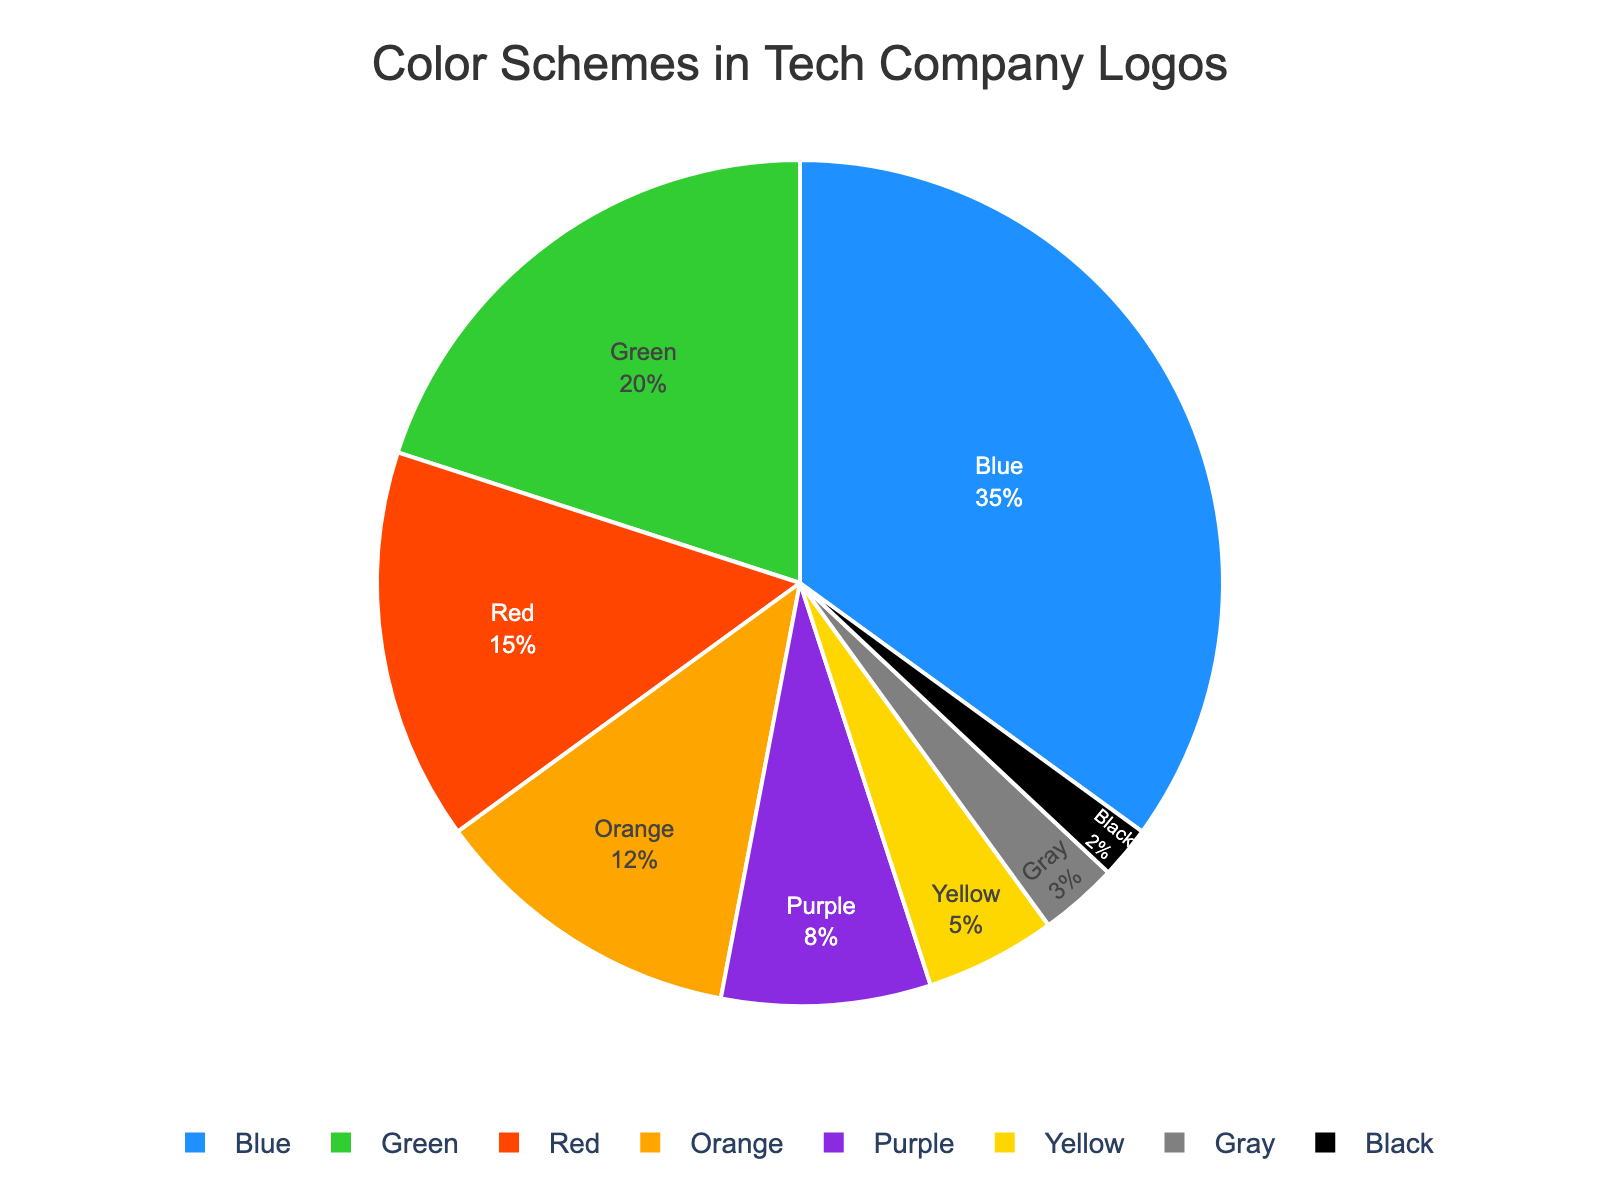Which color scheme is the most commonly used in tech company logos? From the pie chart, Blue holds the largest percentage, indicating it is the most commonly used color scheme.
Answer: Blue Which two colors together account for more than 50% of tech company logos? Blue has 35% and Green has 20%. Adding them together, Blue (35%) + Green (20%) = 55%, which is more than 50%.
Answer: Blue and Green How much more common is the Blue color scheme compared to the Red color scheme in tech company logos? Blue is at 35% and Red is at 15%. The difference is calculated as 35% - 15% = 20%.
Answer: 20% What is the percentage of tech company logos that use either Orange or Purple color schemes? Orange is at 12% and Purple is at 8%. Adding them together, Orange (12%) + Purple (8%) = 20%.
Answer: 20% Which color scheme is used the least in tech company logos? From the pie chart, Black holds the smallest percentage, indicating it is the least used color scheme.
Answer: Black Which color schemes, when combined, equal the percentage usage of Blue? Blue is 35%. The combination of Green (20%) + Red (15%) = 35% matches the percentage of Blue.
Answer: Green and Red Rank the colors from most used to least used based on the chart. The percentages are Blue (35%), Green (20%), Red (15%), Orange (12%), Purple (8%), Yellow (5%), Gray (3%), and Black (2%).
Answer: Blue, Green, Red, Orange, Purple, Yellow, Gray, Black 